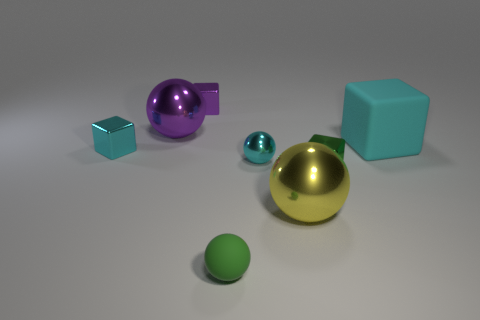Add 2 green rubber objects. How many objects exist? 10 Subtract all metal spheres. How many spheres are left? 1 Subtract 3 spheres. How many spheres are left? 1 Subtract all purple balls. How many balls are left? 3 Subtract all red cubes. Subtract all gray cylinders. How many cubes are left? 4 Subtract all brown cylinders. How many red balls are left? 0 Subtract all small shiny objects. Subtract all large cyan metallic balls. How many objects are left? 4 Add 2 large yellow objects. How many large yellow objects are left? 3 Add 7 big matte things. How many big matte things exist? 8 Subtract 0 blue blocks. How many objects are left? 8 